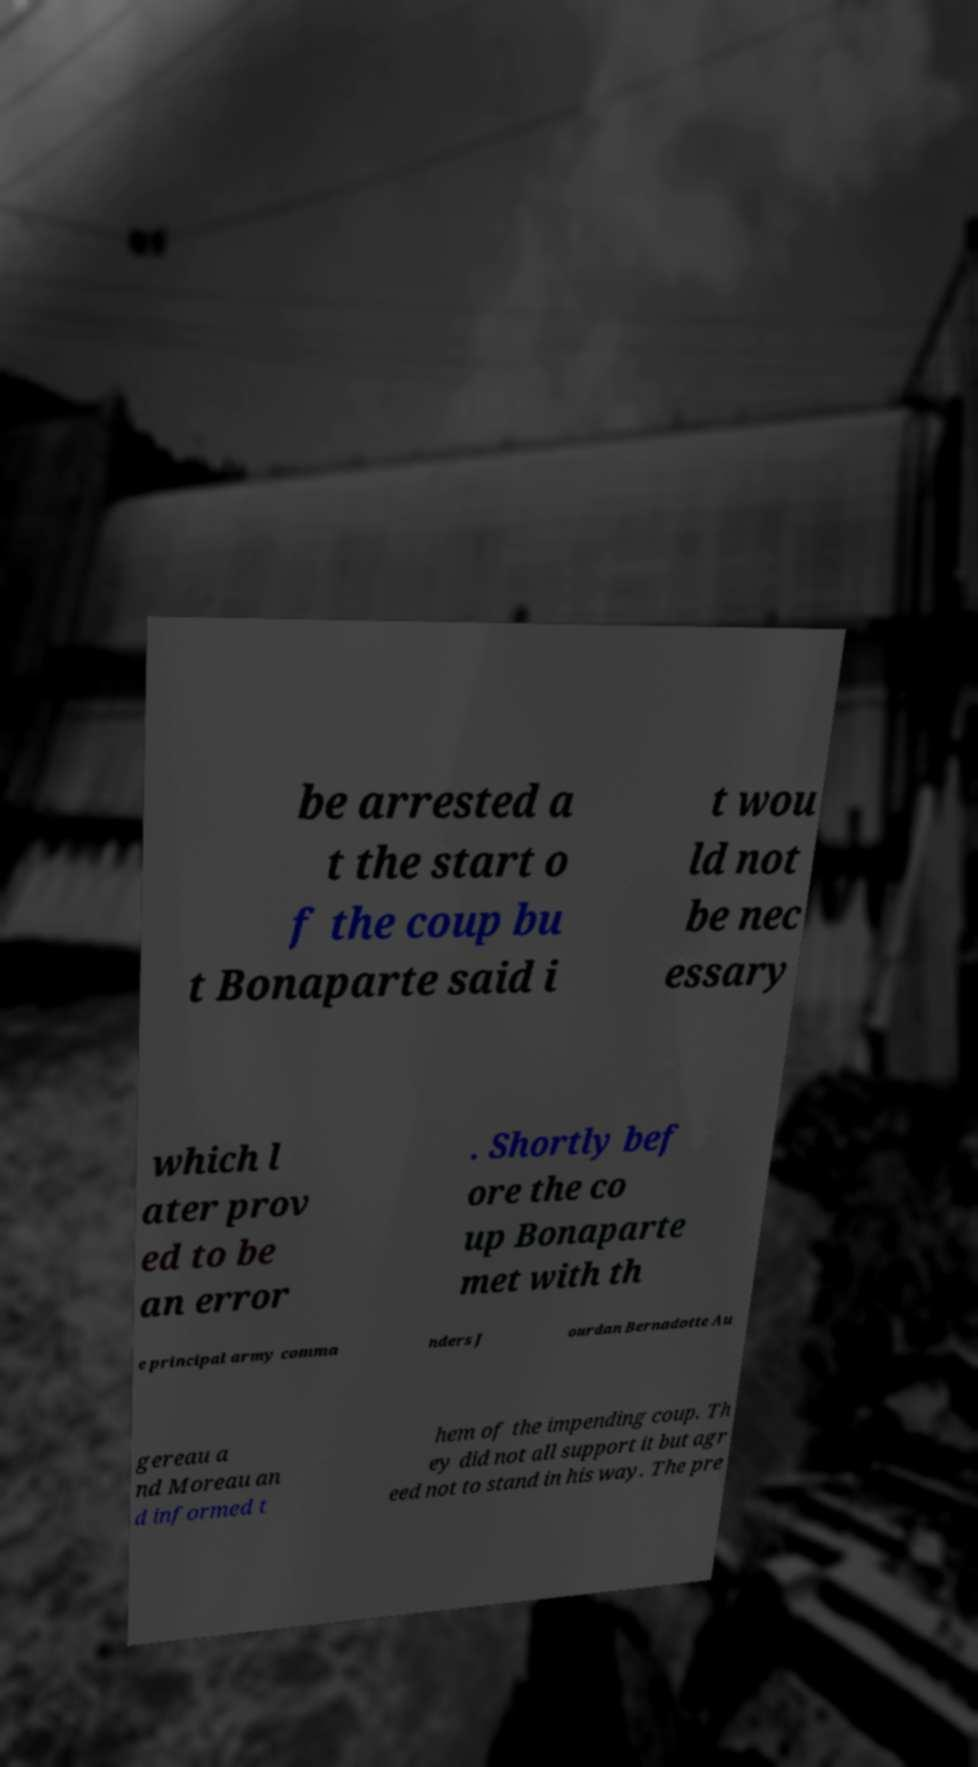For documentation purposes, I need the text within this image transcribed. Could you provide that? be arrested a t the start o f the coup bu t Bonaparte said i t wou ld not be nec essary which l ater prov ed to be an error . Shortly bef ore the co up Bonaparte met with th e principal army comma nders J ourdan Bernadotte Au gereau a nd Moreau an d informed t hem of the impending coup. Th ey did not all support it but agr eed not to stand in his way. The pre 